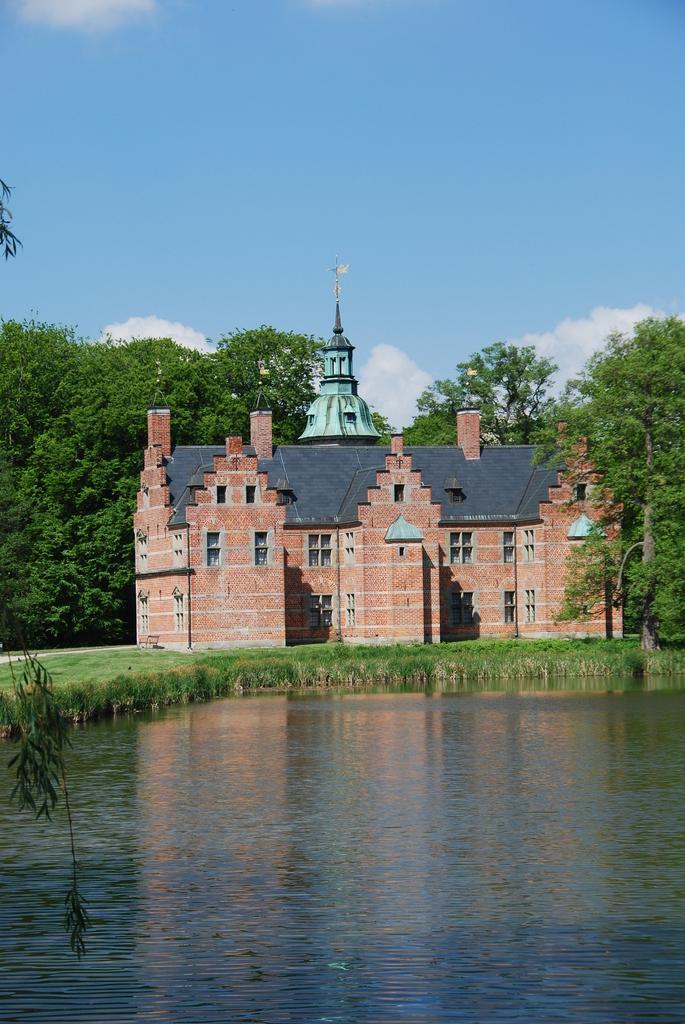In one or two sentences, can you explain what this image depicts? In this picture we can see water, grass and building. On the left side of the image we can see leaves. In the background of the image we can see trees and sky with clouds. 